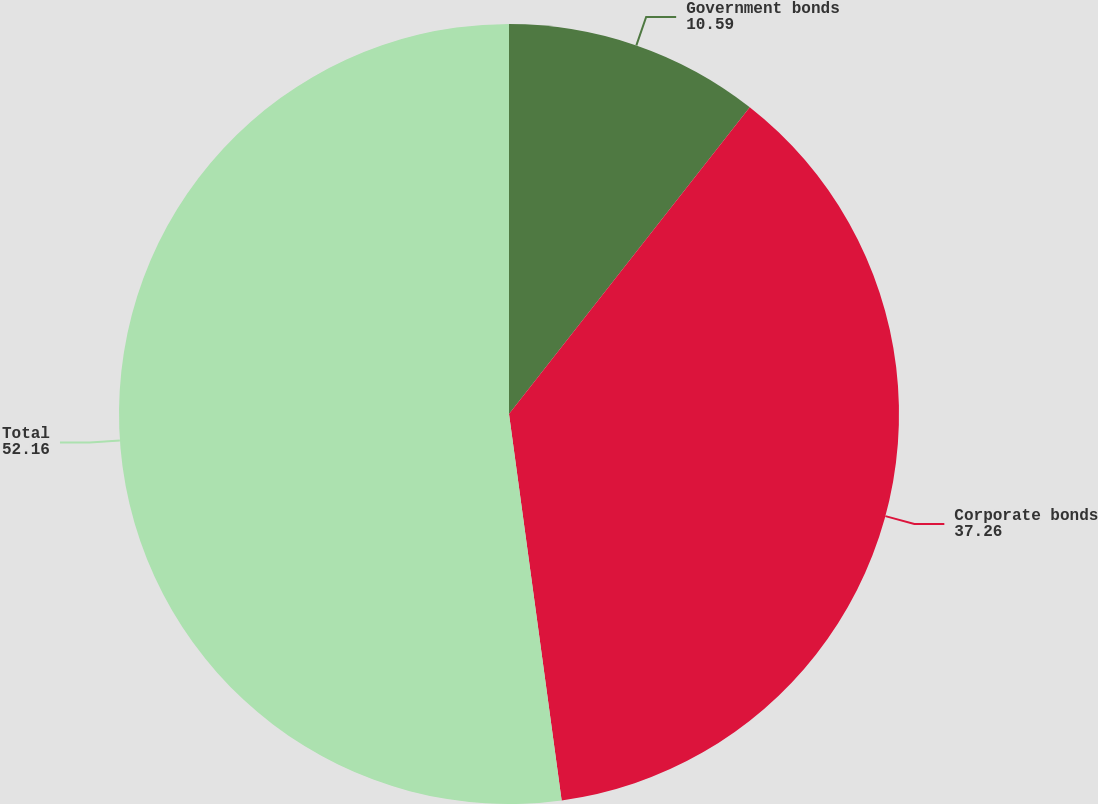Convert chart to OTSL. <chart><loc_0><loc_0><loc_500><loc_500><pie_chart><fcel>Government bonds<fcel>Corporate bonds<fcel>Total<nl><fcel>10.59%<fcel>37.26%<fcel>52.16%<nl></chart> 